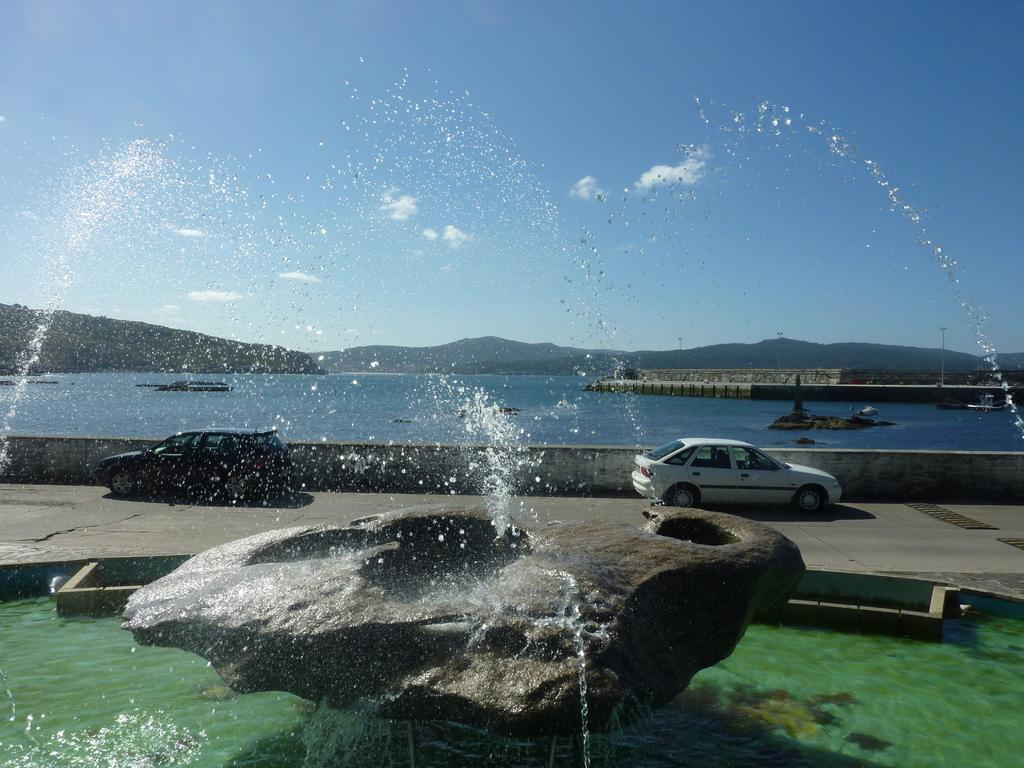What is the main feature in the image? There is a fountain in the image. What else can be seen in the image? Cars are parked on the road in the image. Is there any natural element visible in the image? Yes, there is a river visible in the image. What type of furniture can be seen in the image? There is no furniture present in the image. How much does the journey to the fountain cost in the image? The image does not provide any information about the cost of a journey to the fountain. 